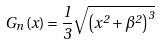<formula> <loc_0><loc_0><loc_500><loc_500>G _ { n } \left ( x \right ) = \frac { 1 } { 3 } \sqrt { \left ( x ^ { 2 } + \beta ^ { 2 } \right ) ^ { 3 } }</formula> 